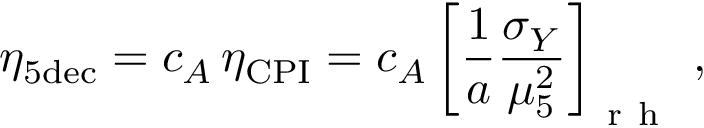Convert formula to latex. <formula><loc_0><loc_0><loc_500><loc_500>\eta _ { 5 d e c } = c _ { A } \, \eta _ { C P I } = c _ { A } \left [ \frac { 1 } { a } \frac { \sigma _ { Y } } { \mu _ { 5 } ^ { 2 } } \right ] _ { r h } \, ,</formula> 